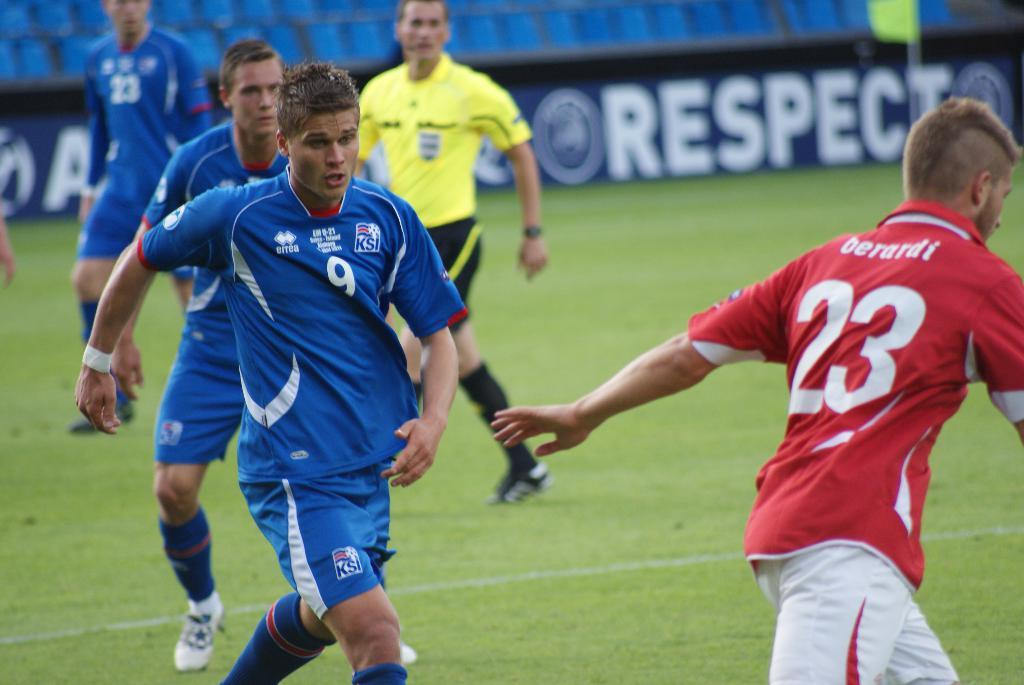<image>
Provide a brief description of the given image. Some men playing sports; the numbers 23 and 9 are visible. 